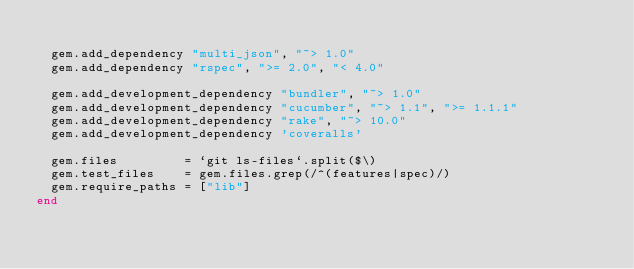Convert code to text. <code><loc_0><loc_0><loc_500><loc_500><_Ruby_>
  gem.add_dependency "multi_json", "~> 1.0"
  gem.add_dependency "rspec", ">= 2.0", "< 4.0"

  gem.add_development_dependency "bundler", "~> 1.0"
  gem.add_development_dependency "cucumber", "~> 1.1", ">= 1.1.1"
  gem.add_development_dependency "rake", "~> 10.0"
  gem.add_development_dependency 'coveralls'

  gem.files         = `git ls-files`.split($\)
  gem.test_files    = gem.files.grep(/^(features|spec)/)
  gem.require_paths = ["lib"]
end
</code> 